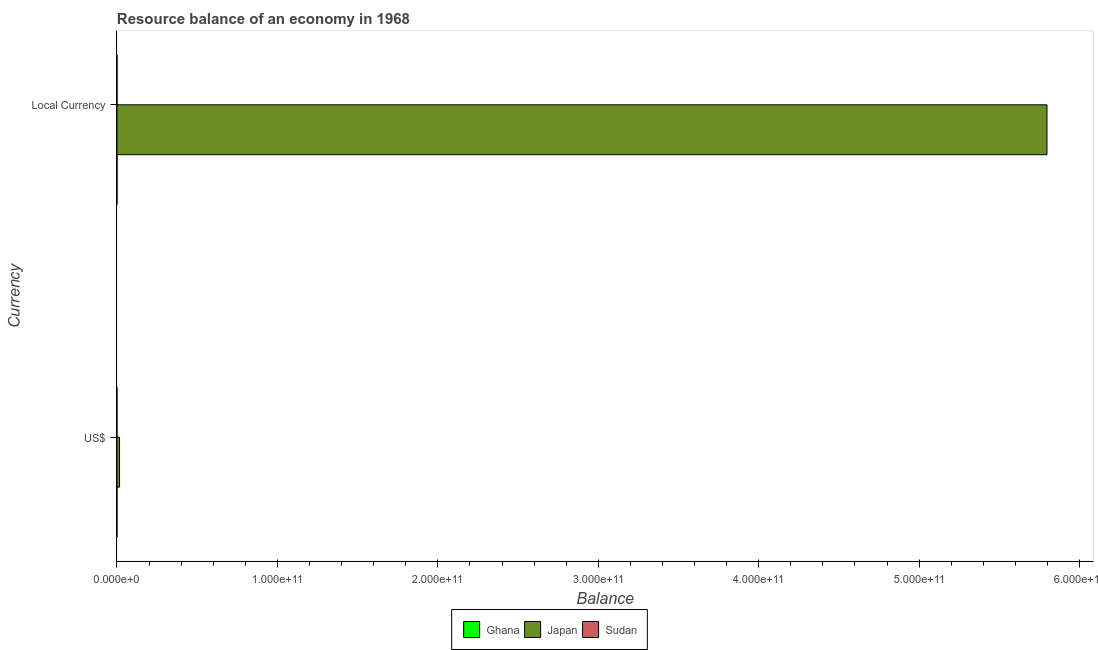How many different coloured bars are there?
Your response must be concise. 1. Are the number of bars per tick equal to the number of legend labels?
Your answer should be compact. No. Are the number of bars on each tick of the Y-axis equal?
Give a very brief answer. Yes. How many bars are there on the 1st tick from the bottom?
Your answer should be very brief. 1. What is the label of the 2nd group of bars from the top?
Provide a short and direct response. US$. Across all countries, what is the maximum resource balance in us$?
Offer a very short reply. 1.61e+09. Across all countries, what is the minimum resource balance in us$?
Offer a very short reply. 0. What is the total resource balance in us$ in the graph?
Your answer should be very brief. 1.61e+09. What is the difference between the resource balance in constant us$ in Japan and the resource balance in us$ in Sudan?
Your answer should be very brief. 5.80e+11. What is the average resource balance in constant us$ per country?
Ensure brevity in your answer.  1.93e+11. What is the difference between the resource balance in us$ and resource balance in constant us$ in Japan?
Provide a succinct answer. -5.78e+11. In how many countries, is the resource balance in us$ greater than the average resource balance in us$ taken over all countries?
Your response must be concise. 1. How many bars are there?
Keep it short and to the point. 2. How many countries are there in the graph?
Ensure brevity in your answer.  3. What is the difference between two consecutive major ticks on the X-axis?
Your answer should be very brief. 1.00e+11. Does the graph contain any zero values?
Give a very brief answer. Yes. Does the graph contain grids?
Give a very brief answer. No. Where does the legend appear in the graph?
Your response must be concise. Bottom center. What is the title of the graph?
Offer a terse response. Resource balance of an economy in 1968. What is the label or title of the X-axis?
Offer a very short reply. Balance. What is the label or title of the Y-axis?
Make the answer very short. Currency. What is the Balance of Ghana in US$?
Your answer should be compact. 0. What is the Balance of Japan in US$?
Your answer should be compact. 1.61e+09. What is the Balance in Sudan in US$?
Offer a very short reply. 0. What is the Balance of Japan in Local Currency?
Your answer should be compact. 5.80e+11. Across all Currency, what is the maximum Balance in Japan?
Offer a terse response. 5.80e+11. Across all Currency, what is the minimum Balance of Japan?
Give a very brief answer. 1.61e+09. What is the total Balance in Ghana in the graph?
Offer a very short reply. 0. What is the total Balance in Japan in the graph?
Provide a short and direct response. 5.81e+11. What is the difference between the Balance of Japan in US$ and that in Local Currency?
Provide a short and direct response. -5.78e+11. What is the average Balance in Ghana per Currency?
Give a very brief answer. 0. What is the average Balance of Japan per Currency?
Offer a very short reply. 2.91e+11. What is the ratio of the Balance in Japan in US$ to that in Local Currency?
Keep it short and to the point. 0. What is the difference between the highest and the second highest Balance in Japan?
Your response must be concise. 5.78e+11. What is the difference between the highest and the lowest Balance of Japan?
Your answer should be very brief. 5.78e+11. 